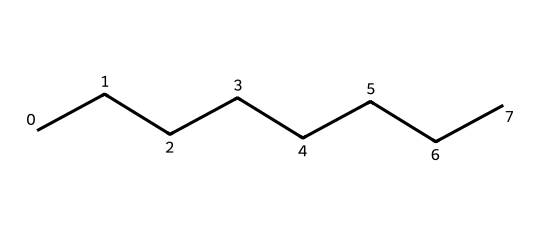What is the molecular formula of octane? The molecular formula can be determined by counting the number of carbon (C) and hydrogen (H) atoms in the structure. The SMILES representation shows 8 carbon atoms and 18 hydrogen atoms.
Answer: C8H18 How many carbon atoms are in octane? The SMILES representation CCCCCCCC indicates that there are 8 sequential carbon atoms present. Hence, we can count them directly from the structure.
Answer: 8 What type of hydrocarbon is octane? Octane consists solely of carbon and hydrogen atoms with single bonds between them, indicating that it is an alkane. Alkanes are non-cyclic hydrocarbons with the general formula CnH(2n+2).
Answer: Alkane What is the significance of octane in fuels? Octane is a significant hydrocarbon in fuel because it has a high energy content and is associated with better combustion efficiency, which is critical for high-performance racing engines.
Answer: High energy content What is the total number of hydrogen atoms in octane? By analyzing the structure, we notice that each carbon in octane forms enough hydrogen bonds to satisfy the tetravalency of carbon. For octane, each terminal carbon is bonded to three hydrogens, while the internal carbons are bonded to two hydrogens. The sum totals to 18 hydrogen atoms.
Answer: 18 Which part of the structure indicates octane's ability to burn efficiently? The long chain of carbon atoms in the structure allows for a larger surface area for combustion and provides a greater number of carbon-hydrogen bonds that release energy when broken in a reaction, contributing to its efficiency in combustion.
Answer: Long carbon chain 